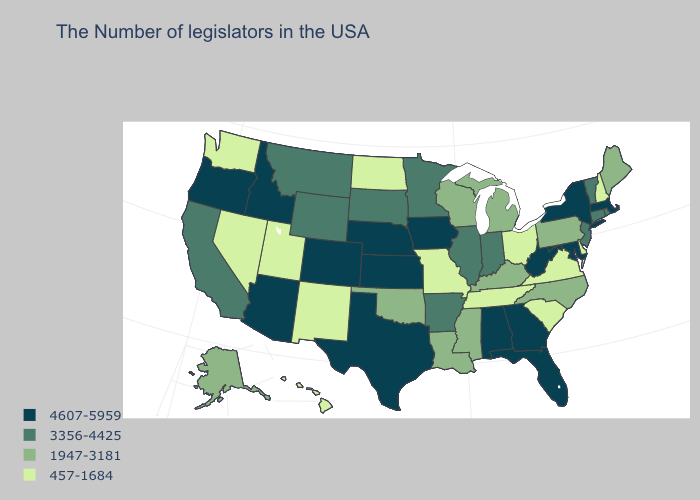Name the states that have a value in the range 4607-5959?
Quick response, please. Massachusetts, New York, Maryland, West Virginia, Florida, Georgia, Alabama, Iowa, Kansas, Nebraska, Texas, Colorado, Arizona, Idaho, Oregon. What is the lowest value in the USA?
Short answer required. 457-1684. Which states have the highest value in the USA?
Write a very short answer. Massachusetts, New York, Maryland, West Virginia, Florida, Georgia, Alabama, Iowa, Kansas, Nebraska, Texas, Colorado, Arizona, Idaho, Oregon. Does Oregon have the same value as Illinois?
Short answer required. No. What is the value of New York?
Answer briefly. 4607-5959. What is the highest value in states that border Louisiana?
Quick response, please. 4607-5959. Among the states that border Minnesota , does South Dakota have the highest value?
Concise answer only. No. What is the value of North Dakota?
Give a very brief answer. 457-1684. Name the states that have a value in the range 1947-3181?
Be succinct. Maine, Pennsylvania, North Carolina, Michigan, Kentucky, Wisconsin, Mississippi, Louisiana, Oklahoma, Alaska. Which states have the lowest value in the MidWest?
Be succinct. Ohio, Missouri, North Dakota. Name the states that have a value in the range 1947-3181?
Give a very brief answer. Maine, Pennsylvania, North Carolina, Michigan, Kentucky, Wisconsin, Mississippi, Louisiana, Oklahoma, Alaska. What is the highest value in states that border California?
Be succinct. 4607-5959. What is the highest value in states that border Alabama?
Answer briefly. 4607-5959. Is the legend a continuous bar?
Concise answer only. No. Does the map have missing data?
Short answer required. No. 